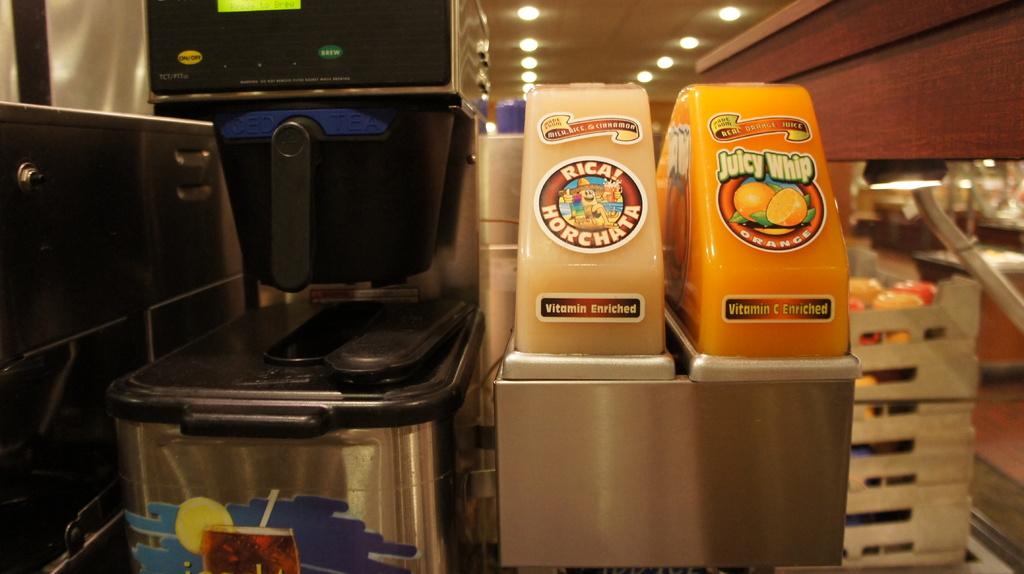What flavors can you drink?
Your response must be concise. Horchata and orange. 